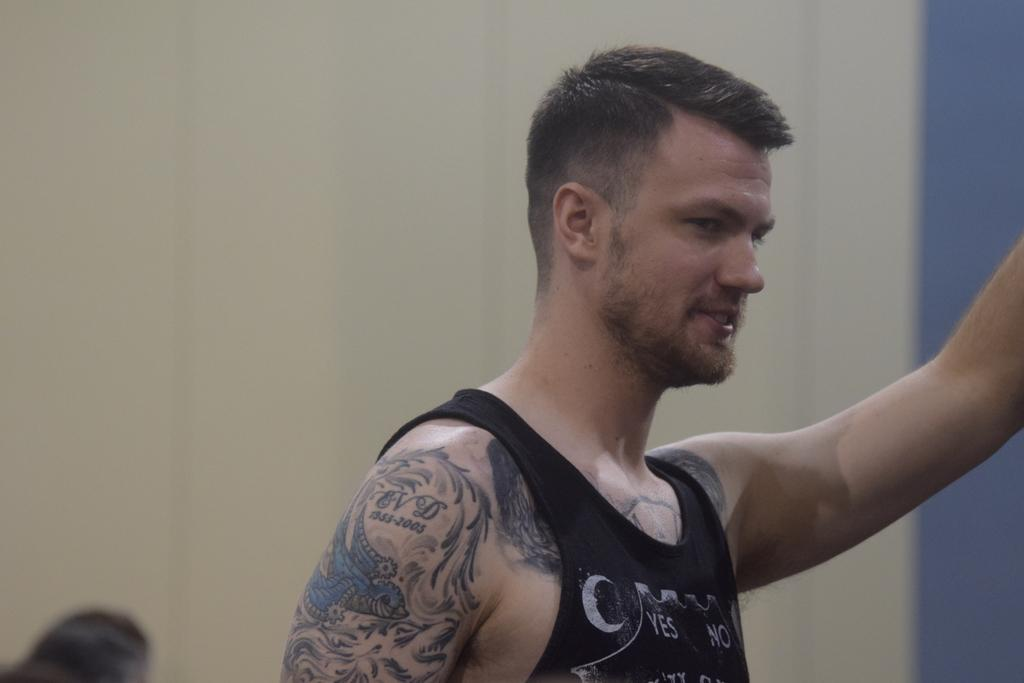What is the main subject of the image? There is a person in the image. What is the person wearing? The person is wearing a dress. What can be seen in the background of the image? There is a wall in the background of the image. What type of journey is the person embarking on in the image? There is no indication in the image that the person is embarking on a journey. Can you tell me how many boys are present in the image? There is no mention of boys in the image; it features a person wearing a dress with a wall in the background. 